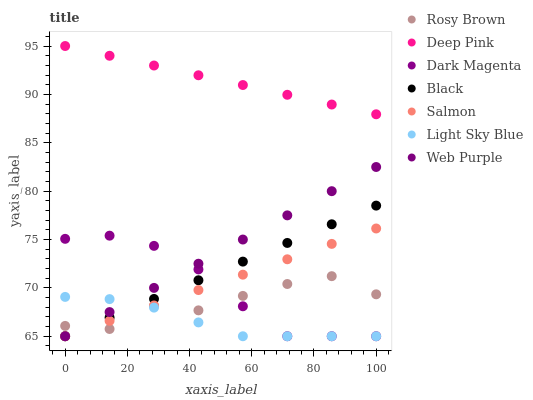Does Light Sky Blue have the minimum area under the curve?
Answer yes or no. Yes. Does Deep Pink have the maximum area under the curve?
Answer yes or no. Yes. Does Dark Magenta have the minimum area under the curve?
Answer yes or no. No. Does Dark Magenta have the maximum area under the curve?
Answer yes or no. No. Is Deep Pink the smoothest?
Answer yes or no. Yes. Is Rosy Brown the roughest?
Answer yes or no. Yes. Is Dark Magenta the smoothest?
Answer yes or no. No. Is Dark Magenta the roughest?
Answer yes or no. No. Does Dark Magenta have the lowest value?
Answer yes or no. Yes. Does Rosy Brown have the lowest value?
Answer yes or no. No. Does Deep Pink have the highest value?
Answer yes or no. Yes. Does Dark Magenta have the highest value?
Answer yes or no. No. Is Light Sky Blue less than Deep Pink?
Answer yes or no. Yes. Is Deep Pink greater than Black?
Answer yes or no. Yes. Does Black intersect Rosy Brown?
Answer yes or no. Yes. Is Black less than Rosy Brown?
Answer yes or no. No. Is Black greater than Rosy Brown?
Answer yes or no. No. Does Light Sky Blue intersect Deep Pink?
Answer yes or no. No. 